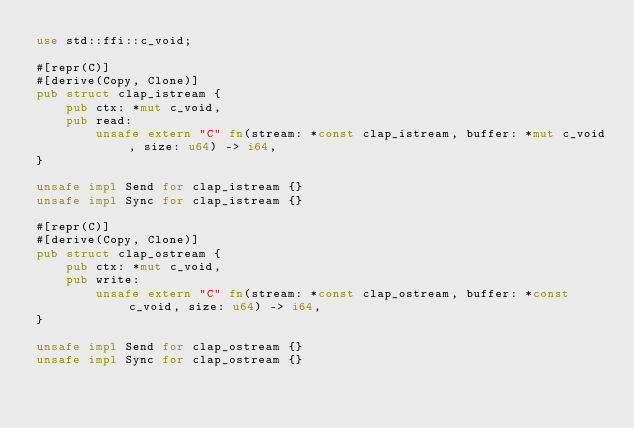Convert code to text. <code><loc_0><loc_0><loc_500><loc_500><_Rust_>use std::ffi::c_void;

#[repr(C)]
#[derive(Copy, Clone)]
pub struct clap_istream {
    pub ctx: *mut c_void,
    pub read:
        unsafe extern "C" fn(stream: *const clap_istream, buffer: *mut c_void, size: u64) -> i64,
}

unsafe impl Send for clap_istream {}
unsafe impl Sync for clap_istream {}

#[repr(C)]
#[derive(Copy, Clone)]
pub struct clap_ostream {
    pub ctx: *mut c_void,
    pub write:
        unsafe extern "C" fn(stream: *const clap_ostream, buffer: *const c_void, size: u64) -> i64,
}

unsafe impl Send for clap_ostream {}
unsafe impl Sync for clap_ostream {}
</code> 